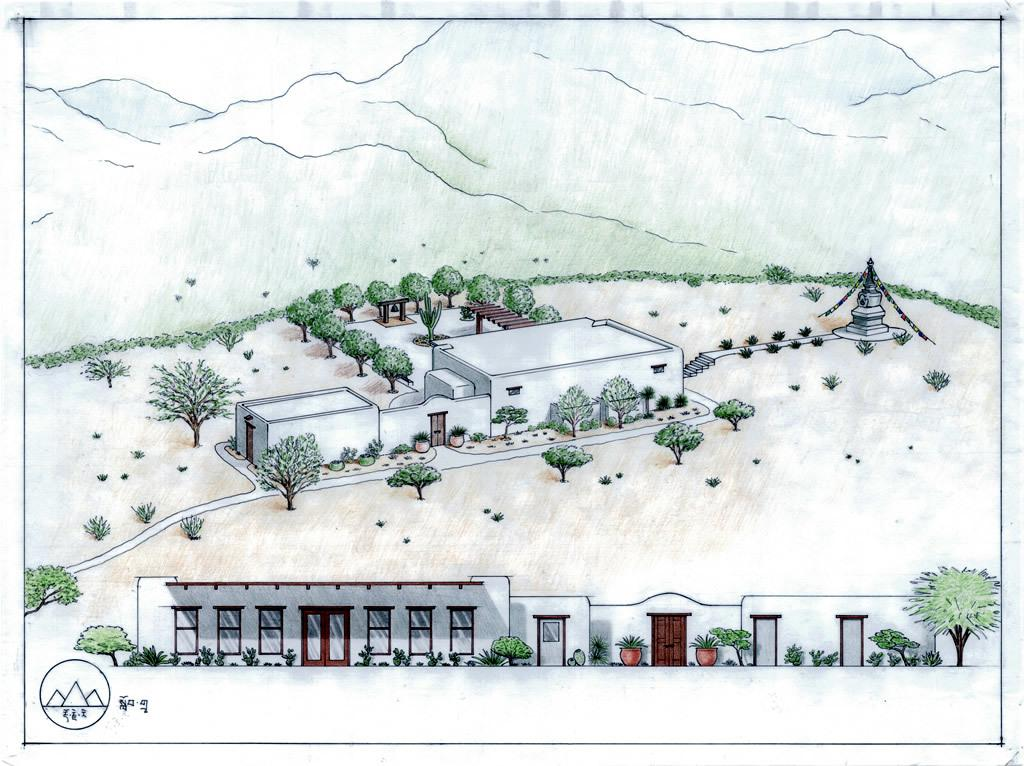What type of drawing is the image? The image is a sketch. What structures can be seen in the sketch? There are houses, a tower, and mountains in the sketch. What type of vegetation is present in the sketch? There are trees and plants in the sketch, including house plants. What additional elements are present at the bottom of the sketch? There is a logo and some text at the bottom of the sketch. What type of song is being sung by the trees in the sketch? There are no trees singing in the sketch; it is a drawing and does not depict any sounds or songs. 